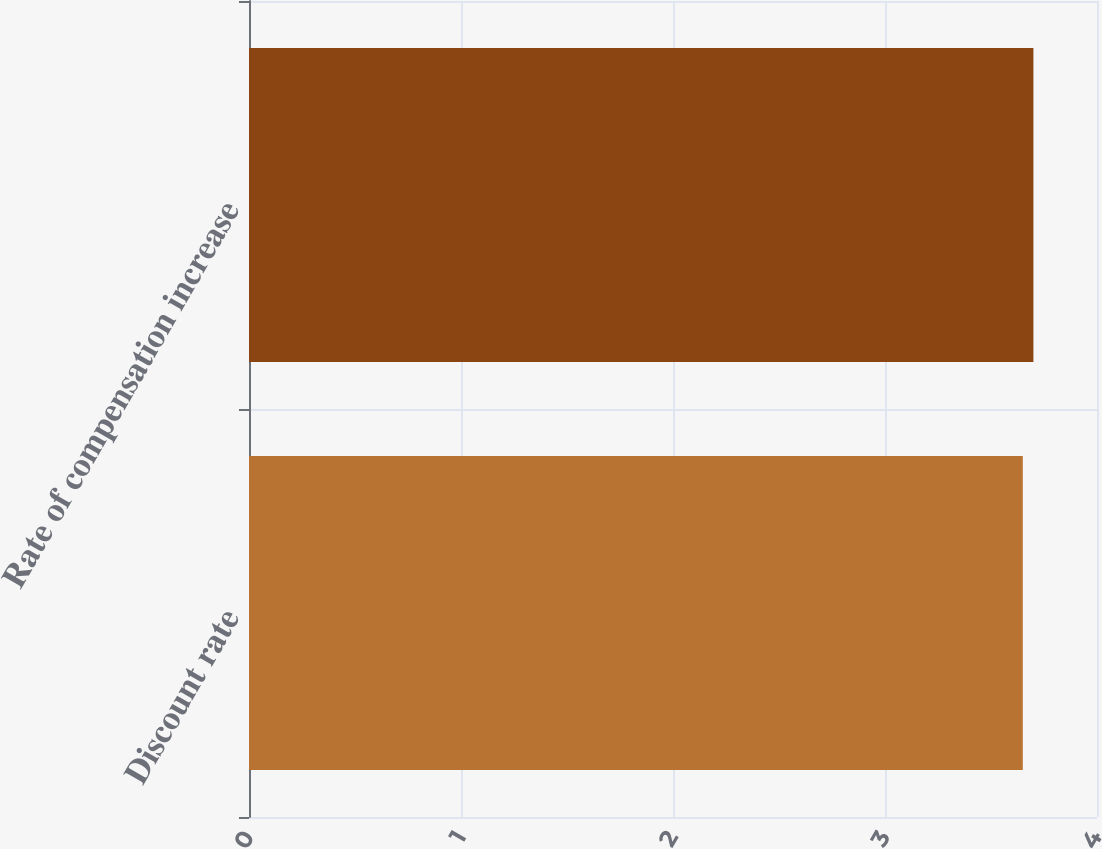Convert chart to OTSL. <chart><loc_0><loc_0><loc_500><loc_500><bar_chart><fcel>Discount rate<fcel>Rate of compensation increase<nl><fcel>3.65<fcel>3.7<nl></chart> 